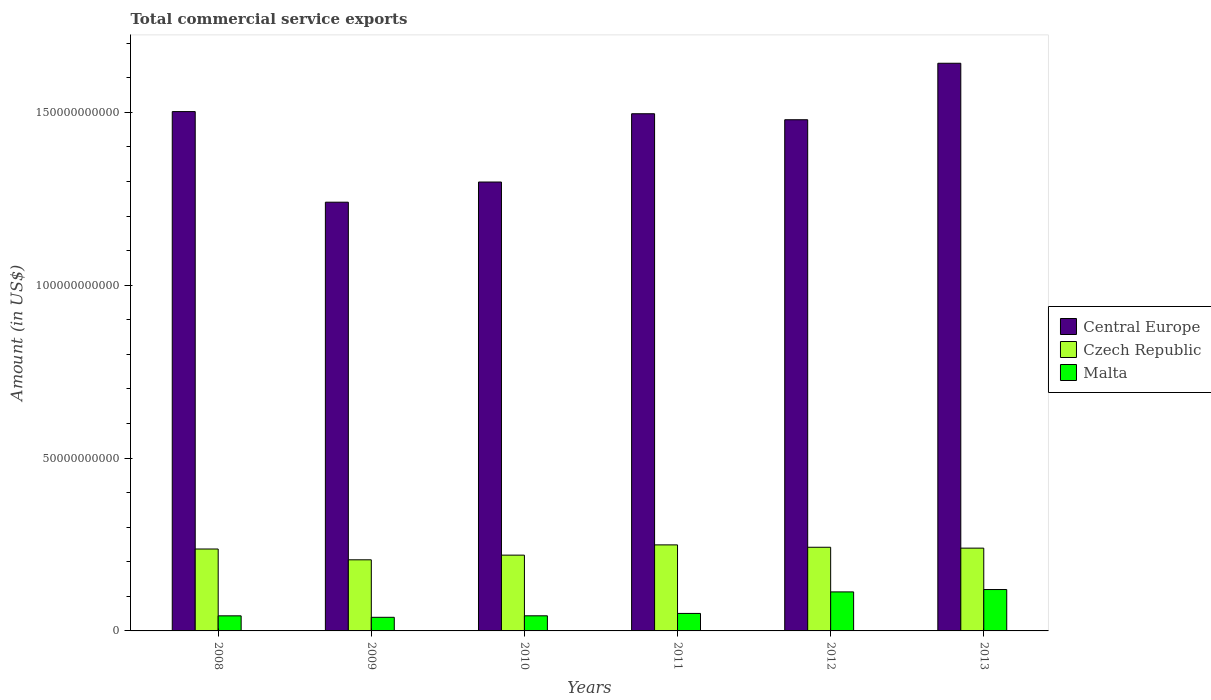Are the number of bars per tick equal to the number of legend labels?
Offer a very short reply. Yes. Are the number of bars on each tick of the X-axis equal?
Your response must be concise. Yes. How many bars are there on the 3rd tick from the left?
Your answer should be very brief. 3. How many bars are there on the 1st tick from the right?
Keep it short and to the point. 3. What is the total commercial service exports in Central Europe in 2008?
Provide a succinct answer. 1.50e+11. Across all years, what is the maximum total commercial service exports in Malta?
Make the answer very short. 1.20e+1. Across all years, what is the minimum total commercial service exports in Czech Republic?
Your response must be concise. 2.06e+1. In which year was the total commercial service exports in Czech Republic maximum?
Provide a short and direct response. 2011. In which year was the total commercial service exports in Central Europe minimum?
Provide a short and direct response. 2009. What is the total total commercial service exports in Czech Republic in the graph?
Your answer should be compact. 1.39e+11. What is the difference between the total commercial service exports in Czech Republic in 2009 and that in 2010?
Provide a succinct answer. -1.35e+09. What is the difference between the total commercial service exports in Central Europe in 2011 and the total commercial service exports in Czech Republic in 2009?
Keep it short and to the point. 1.29e+11. What is the average total commercial service exports in Central Europe per year?
Provide a short and direct response. 1.44e+11. In the year 2010, what is the difference between the total commercial service exports in Czech Republic and total commercial service exports in Central Europe?
Give a very brief answer. -1.08e+11. What is the ratio of the total commercial service exports in Central Europe in 2009 to that in 2012?
Provide a short and direct response. 0.84. Is the difference between the total commercial service exports in Czech Republic in 2008 and 2013 greater than the difference between the total commercial service exports in Central Europe in 2008 and 2013?
Offer a terse response. Yes. What is the difference between the highest and the second highest total commercial service exports in Malta?
Offer a very short reply. 6.85e+08. What is the difference between the highest and the lowest total commercial service exports in Czech Republic?
Keep it short and to the point. 4.32e+09. What does the 1st bar from the left in 2012 represents?
Ensure brevity in your answer.  Central Europe. What does the 3rd bar from the right in 2012 represents?
Offer a very short reply. Central Europe. How many bars are there?
Provide a succinct answer. 18. Are all the bars in the graph horizontal?
Keep it short and to the point. No. What is the difference between two consecutive major ticks on the Y-axis?
Ensure brevity in your answer.  5.00e+1. Does the graph contain grids?
Your response must be concise. No. How many legend labels are there?
Keep it short and to the point. 3. How are the legend labels stacked?
Give a very brief answer. Vertical. What is the title of the graph?
Offer a very short reply. Total commercial service exports. What is the Amount (in US$) of Central Europe in 2008?
Your response must be concise. 1.50e+11. What is the Amount (in US$) in Czech Republic in 2008?
Offer a very short reply. 2.37e+1. What is the Amount (in US$) of Malta in 2008?
Your response must be concise. 4.37e+09. What is the Amount (in US$) of Central Europe in 2009?
Your answer should be compact. 1.24e+11. What is the Amount (in US$) in Czech Republic in 2009?
Give a very brief answer. 2.06e+1. What is the Amount (in US$) of Malta in 2009?
Offer a very short reply. 3.94e+09. What is the Amount (in US$) in Central Europe in 2010?
Make the answer very short. 1.30e+11. What is the Amount (in US$) in Czech Republic in 2010?
Keep it short and to the point. 2.19e+1. What is the Amount (in US$) in Malta in 2010?
Your answer should be very brief. 4.37e+09. What is the Amount (in US$) of Central Europe in 2011?
Your response must be concise. 1.50e+11. What is the Amount (in US$) of Czech Republic in 2011?
Give a very brief answer. 2.49e+1. What is the Amount (in US$) of Malta in 2011?
Give a very brief answer. 5.06e+09. What is the Amount (in US$) in Central Europe in 2012?
Offer a very short reply. 1.48e+11. What is the Amount (in US$) in Czech Republic in 2012?
Your answer should be compact. 2.42e+1. What is the Amount (in US$) of Malta in 2012?
Provide a succinct answer. 1.13e+1. What is the Amount (in US$) in Central Europe in 2013?
Your answer should be compact. 1.64e+11. What is the Amount (in US$) in Czech Republic in 2013?
Provide a succinct answer. 2.39e+1. What is the Amount (in US$) of Malta in 2013?
Make the answer very short. 1.20e+1. Across all years, what is the maximum Amount (in US$) in Central Europe?
Provide a short and direct response. 1.64e+11. Across all years, what is the maximum Amount (in US$) in Czech Republic?
Give a very brief answer. 2.49e+1. Across all years, what is the maximum Amount (in US$) of Malta?
Provide a succinct answer. 1.20e+1. Across all years, what is the minimum Amount (in US$) of Central Europe?
Offer a terse response. 1.24e+11. Across all years, what is the minimum Amount (in US$) of Czech Republic?
Keep it short and to the point. 2.06e+1. Across all years, what is the minimum Amount (in US$) of Malta?
Make the answer very short. 3.94e+09. What is the total Amount (in US$) in Central Europe in the graph?
Offer a very short reply. 8.66e+11. What is the total Amount (in US$) in Czech Republic in the graph?
Offer a very short reply. 1.39e+11. What is the total Amount (in US$) in Malta in the graph?
Make the answer very short. 4.10e+1. What is the difference between the Amount (in US$) in Central Europe in 2008 and that in 2009?
Your answer should be very brief. 2.62e+1. What is the difference between the Amount (in US$) in Czech Republic in 2008 and that in 2009?
Keep it short and to the point. 3.12e+09. What is the difference between the Amount (in US$) in Malta in 2008 and that in 2009?
Ensure brevity in your answer.  4.28e+08. What is the difference between the Amount (in US$) of Central Europe in 2008 and that in 2010?
Ensure brevity in your answer.  2.04e+1. What is the difference between the Amount (in US$) of Czech Republic in 2008 and that in 2010?
Provide a short and direct response. 1.77e+09. What is the difference between the Amount (in US$) in Malta in 2008 and that in 2010?
Provide a succinct answer. -8.65e+06. What is the difference between the Amount (in US$) of Central Europe in 2008 and that in 2011?
Offer a terse response. 6.25e+08. What is the difference between the Amount (in US$) of Czech Republic in 2008 and that in 2011?
Ensure brevity in your answer.  -1.19e+09. What is the difference between the Amount (in US$) of Malta in 2008 and that in 2011?
Offer a very short reply. -6.96e+08. What is the difference between the Amount (in US$) of Central Europe in 2008 and that in 2012?
Your answer should be compact. 2.36e+09. What is the difference between the Amount (in US$) in Czech Republic in 2008 and that in 2012?
Your answer should be very brief. -5.06e+08. What is the difference between the Amount (in US$) in Malta in 2008 and that in 2012?
Offer a very short reply. -6.92e+09. What is the difference between the Amount (in US$) of Central Europe in 2008 and that in 2013?
Make the answer very short. -1.40e+1. What is the difference between the Amount (in US$) of Czech Republic in 2008 and that in 2013?
Provide a short and direct response. -2.54e+08. What is the difference between the Amount (in US$) in Malta in 2008 and that in 2013?
Keep it short and to the point. -7.61e+09. What is the difference between the Amount (in US$) of Central Europe in 2009 and that in 2010?
Give a very brief answer. -5.83e+09. What is the difference between the Amount (in US$) in Czech Republic in 2009 and that in 2010?
Provide a succinct answer. -1.35e+09. What is the difference between the Amount (in US$) in Malta in 2009 and that in 2010?
Provide a succinct answer. -4.36e+08. What is the difference between the Amount (in US$) in Central Europe in 2009 and that in 2011?
Make the answer very short. -2.56e+1. What is the difference between the Amount (in US$) in Czech Republic in 2009 and that in 2011?
Provide a succinct answer. -4.32e+09. What is the difference between the Amount (in US$) in Malta in 2009 and that in 2011?
Give a very brief answer. -1.12e+09. What is the difference between the Amount (in US$) in Central Europe in 2009 and that in 2012?
Provide a short and direct response. -2.39e+1. What is the difference between the Amount (in US$) of Czech Republic in 2009 and that in 2012?
Make the answer very short. -3.63e+09. What is the difference between the Amount (in US$) of Malta in 2009 and that in 2012?
Provide a short and direct response. -7.35e+09. What is the difference between the Amount (in US$) in Central Europe in 2009 and that in 2013?
Ensure brevity in your answer.  -4.02e+1. What is the difference between the Amount (in US$) of Czech Republic in 2009 and that in 2013?
Your response must be concise. -3.38e+09. What is the difference between the Amount (in US$) in Malta in 2009 and that in 2013?
Provide a short and direct response. -8.03e+09. What is the difference between the Amount (in US$) of Central Europe in 2010 and that in 2011?
Keep it short and to the point. -1.98e+1. What is the difference between the Amount (in US$) in Czech Republic in 2010 and that in 2011?
Offer a very short reply. -2.96e+09. What is the difference between the Amount (in US$) of Malta in 2010 and that in 2011?
Provide a short and direct response. -6.87e+08. What is the difference between the Amount (in US$) of Central Europe in 2010 and that in 2012?
Give a very brief answer. -1.80e+1. What is the difference between the Amount (in US$) in Czech Republic in 2010 and that in 2012?
Make the answer very short. -2.28e+09. What is the difference between the Amount (in US$) of Malta in 2010 and that in 2012?
Keep it short and to the point. -6.91e+09. What is the difference between the Amount (in US$) of Central Europe in 2010 and that in 2013?
Offer a very short reply. -3.44e+1. What is the difference between the Amount (in US$) of Czech Republic in 2010 and that in 2013?
Provide a short and direct response. -2.02e+09. What is the difference between the Amount (in US$) in Malta in 2010 and that in 2013?
Your answer should be very brief. -7.60e+09. What is the difference between the Amount (in US$) in Central Europe in 2011 and that in 2012?
Make the answer very short. 1.73e+09. What is the difference between the Amount (in US$) in Czech Republic in 2011 and that in 2012?
Offer a very short reply. 6.84e+08. What is the difference between the Amount (in US$) of Malta in 2011 and that in 2012?
Keep it short and to the point. -6.23e+09. What is the difference between the Amount (in US$) of Central Europe in 2011 and that in 2013?
Give a very brief answer. -1.46e+1. What is the difference between the Amount (in US$) in Czech Republic in 2011 and that in 2013?
Offer a terse response. 9.36e+08. What is the difference between the Amount (in US$) of Malta in 2011 and that in 2013?
Your response must be concise. -6.91e+09. What is the difference between the Amount (in US$) of Central Europe in 2012 and that in 2013?
Your response must be concise. -1.63e+1. What is the difference between the Amount (in US$) in Czech Republic in 2012 and that in 2013?
Provide a short and direct response. 2.52e+08. What is the difference between the Amount (in US$) in Malta in 2012 and that in 2013?
Offer a terse response. -6.85e+08. What is the difference between the Amount (in US$) in Central Europe in 2008 and the Amount (in US$) in Czech Republic in 2009?
Offer a very short reply. 1.30e+11. What is the difference between the Amount (in US$) of Central Europe in 2008 and the Amount (in US$) of Malta in 2009?
Keep it short and to the point. 1.46e+11. What is the difference between the Amount (in US$) in Czech Republic in 2008 and the Amount (in US$) in Malta in 2009?
Give a very brief answer. 1.98e+1. What is the difference between the Amount (in US$) in Central Europe in 2008 and the Amount (in US$) in Czech Republic in 2010?
Provide a succinct answer. 1.28e+11. What is the difference between the Amount (in US$) in Central Europe in 2008 and the Amount (in US$) in Malta in 2010?
Provide a short and direct response. 1.46e+11. What is the difference between the Amount (in US$) in Czech Republic in 2008 and the Amount (in US$) in Malta in 2010?
Your answer should be compact. 1.93e+1. What is the difference between the Amount (in US$) of Central Europe in 2008 and the Amount (in US$) of Czech Republic in 2011?
Your response must be concise. 1.25e+11. What is the difference between the Amount (in US$) of Central Europe in 2008 and the Amount (in US$) of Malta in 2011?
Provide a succinct answer. 1.45e+11. What is the difference between the Amount (in US$) of Czech Republic in 2008 and the Amount (in US$) of Malta in 2011?
Keep it short and to the point. 1.86e+1. What is the difference between the Amount (in US$) in Central Europe in 2008 and the Amount (in US$) in Czech Republic in 2012?
Provide a succinct answer. 1.26e+11. What is the difference between the Amount (in US$) in Central Europe in 2008 and the Amount (in US$) in Malta in 2012?
Provide a succinct answer. 1.39e+11. What is the difference between the Amount (in US$) in Czech Republic in 2008 and the Amount (in US$) in Malta in 2012?
Your answer should be compact. 1.24e+1. What is the difference between the Amount (in US$) in Central Europe in 2008 and the Amount (in US$) in Czech Republic in 2013?
Provide a short and direct response. 1.26e+11. What is the difference between the Amount (in US$) of Central Europe in 2008 and the Amount (in US$) of Malta in 2013?
Give a very brief answer. 1.38e+11. What is the difference between the Amount (in US$) in Czech Republic in 2008 and the Amount (in US$) in Malta in 2013?
Your answer should be very brief. 1.17e+1. What is the difference between the Amount (in US$) of Central Europe in 2009 and the Amount (in US$) of Czech Republic in 2010?
Offer a very short reply. 1.02e+11. What is the difference between the Amount (in US$) of Central Europe in 2009 and the Amount (in US$) of Malta in 2010?
Give a very brief answer. 1.20e+11. What is the difference between the Amount (in US$) in Czech Republic in 2009 and the Amount (in US$) in Malta in 2010?
Make the answer very short. 1.62e+1. What is the difference between the Amount (in US$) of Central Europe in 2009 and the Amount (in US$) of Czech Republic in 2011?
Offer a very short reply. 9.91e+1. What is the difference between the Amount (in US$) in Central Europe in 2009 and the Amount (in US$) in Malta in 2011?
Keep it short and to the point. 1.19e+11. What is the difference between the Amount (in US$) of Czech Republic in 2009 and the Amount (in US$) of Malta in 2011?
Ensure brevity in your answer.  1.55e+1. What is the difference between the Amount (in US$) in Central Europe in 2009 and the Amount (in US$) in Czech Republic in 2012?
Ensure brevity in your answer.  9.98e+1. What is the difference between the Amount (in US$) of Central Europe in 2009 and the Amount (in US$) of Malta in 2012?
Give a very brief answer. 1.13e+11. What is the difference between the Amount (in US$) in Czech Republic in 2009 and the Amount (in US$) in Malta in 2012?
Your answer should be very brief. 9.28e+09. What is the difference between the Amount (in US$) in Central Europe in 2009 and the Amount (in US$) in Czech Republic in 2013?
Offer a very short reply. 1.00e+11. What is the difference between the Amount (in US$) in Central Europe in 2009 and the Amount (in US$) in Malta in 2013?
Ensure brevity in your answer.  1.12e+11. What is the difference between the Amount (in US$) of Czech Republic in 2009 and the Amount (in US$) of Malta in 2013?
Your answer should be very brief. 8.60e+09. What is the difference between the Amount (in US$) of Central Europe in 2010 and the Amount (in US$) of Czech Republic in 2011?
Provide a succinct answer. 1.05e+11. What is the difference between the Amount (in US$) of Central Europe in 2010 and the Amount (in US$) of Malta in 2011?
Give a very brief answer. 1.25e+11. What is the difference between the Amount (in US$) in Czech Republic in 2010 and the Amount (in US$) in Malta in 2011?
Provide a succinct answer. 1.69e+1. What is the difference between the Amount (in US$) in Central Europe in 2010 and the Amount (in US$) in Czech Republic in 2012?
Ensure brevity in your answer.  1.06e+11. What is the difference between the Amount (in US$) in Central Europe in 2010 and the Amount (in US$) in Malta in 2012?
Make the answer very short. 1.19e+11. What is the difference between the Amount (in US$) of Czech Republic in 2010 and the Amount (in US$) of Malta in 2012?
Your answer should be very brief. 1.06e+1. What is the difference between the Amount (in US$) of Central Europe in 2010 and the Amount (in US$) of Czech Republic in 2013?
Your answer should be compact. 1.06e+11. What is the difference between the Amount (in US$) in Central Europe in 2010 and the Amount (in US$) in Malta in 2013?
Give a very brief answer. 1.18e+11. What is the difference between the Amount (in US$) of Czech Republic in 2010 and the Amount (in US$) of Malta in 2013?
Your answer should be very brief. 9.95e+09. What is the difference between the Amount (in US$) of Central Europe in 2011 and the Amount (in US$) of Czech Republic in 2012?
Your answer should be compact. 1.25e+11. What is the difference between the Amount (in US$) of Central Europe in 2011 and the Amount (in US$) of Malta in 2012?
Your answer should be very brief. 1.38e+11. What is the difference between the Amount (in US$) of Czech Republic in 2011 and the Amount (in US$) of Malta in 2012?
Keep it short and to the point. 1.36e+1. What is the difference between the Amount (in US$) in Central Europe in 2011 and the Amount (in US$) in Czech Republic in 2013?
Your answer should be very brief. 1.26e+11. What is the difference between the Amount (in US$) of Central Europe in 2011 and the Amount (in US$) of Malta in 2013?
Your answer should be compact. 1.38e+11. What is the difference between the Amount (in US$) of Czech Republic in 2011 and the Amount (in US$) of Malta in 2013?
Provide a short and direct response. 1.29e+1. What is the difference between the Amount (in US$) in Central Europe in 2012 and the Amount (in US$) in Czech Republic in 2013?
Give a very brief answer. 1.24e+11. What is the difference between the Amount (in US$) of Central Europe in 2012 and the Amount (in US$) of Malta in 2013?
Offer a very short reply. 1.36e+11. What is the difference between the Amount (in US$) of Czech Republic in 2012 and the Amount (in US$) of Malta in 2013?
Provide a succinct answer. 1.22e+1. What is the average Amount (in US$) in Central Europe per year?
Offer a terse response. 1.44e+11. What is the average Amount (in US$) of Czech Republic per year?
Provide a short and direct response. 2.32e+1. What is the average Amount (in US$) of Malta per year?
Ensure brevity in your answer.  6.83e+09. In the year 2008, what is the difference between the Amount (in US$) in Central Europe and Amount (in US$) in Czech Republic?
Ensure brevity in your answer.  1.27e+11. In the year 2008, what is the difference between the Amount (in US$) of Central Europe and Amount (in US$) of Malta?
Make the answer very short. 1.46e+11. In the year 2008, what is the difference between the Amount (in US$) of Czech Republic and Amount (in US$) of Malta?
Offer a very short reply. 1.93e+1. In the year 2009, what is the difference between the Amount (in US$) in Central Europe and Amount (in US$) in Czech Republic?
Provide a succinct answer. 1.03e+11. In the year 2009, what is the difference between the Amount (in US$) of Central Europe and Amount (in US$) of Malta?
Your response must be concise. 1.20e+11. In the year 2009, what is the difference between the Amount (in US$) in Czech Republic and Amount (in US$) in Malta?
Your answer should be very brief. 1.66e+1. In the year 2010, what is the difference between the Amount (in US$) of Central Europe and Amount (in US$) of Czech Republic?
Keep it short and to the point. 1.08e+11. In the year 2010, what is the difference between the Amount (in US$) in Central Europe and Amount (in US$) in Malta?
Your response must be concise. 1.25e+11. In the year 2010, what is the difference between the Amount (in US$) in Czech Republic and Amount (in US$) in Malta?
Provide a succinct answer. 1.76e+1. In the year 2011, what is the difference between the Amount (in US$) in Central Europe and Amount (in US$) in Czech Republic?
Offer a terse response. 1.25e+11. In the year 2011, what is the difference between the Amount (in US$) in Central Europe and Amount (in US$) in Malta?
Keep it short and to the point. 1.45e+11. In the year 2011, what is the difference between the Amount (in US$) of Czech Republic and Amount (in US$) of Malta?
Your response must be concise. 1.98e+1. In the year 2012, what is the difference between the Amount (in US$) in Central Europe and Amount (in US$) in Czech Republic?
Your answer should be compact. 1.24e+11. In the year 2012, what is the difference between the Amount (in US$) of Central Europe and Amount (in US$) of Malta?
Give a very brief answer. 1.37e+11. In the year 2012, what is the difference between the Amount (in US$) of Czech Republic and Amount (in US$) of Malta?
Your answer should be compact. 1.29e+1. In the year 2013, what is the difference between the Amount (in US$) of Central Europe and Amount (in US$) of Czech Republic?
Keep it short and to the point. 1.40e+11. In the year 2013, what is the difference between the Amount (in US$) of Central Europe and Amount (in US$) of Malta?
Offer a terse response. 1.52e+11. In the year 2013, what is the difference between the Amount (in US$) of Czech Republic and Amount (in US$) of Malta?
Keep it short and to the point. 1.20e+1. What is the ratio of the Amount (in US$) in Central Europe in 2008 to that in 2009?
Your response must be concise. 1.21. What is the ratio of the Amount (in US$) in Czech Republic in 2008 to that in 2009?
Your response must be concise. 1.15. What is the ratio of the Amount (in US$) in Malta in 2008 to that in 2009?
Provide a succinct answer. 1.11. What is the ratio of the Amount (in US$) of Central Europe in 2008 to that in 2010?
Offer a terse response. 1.16. What is the ratio of the Amount (in US$) of Czech Republic in 2008 to that in 2010?
Your response must be concise. 1.08. What is the ratio of the Amount (in US$) of Czech Republic in 2008 to that in 2011?
Ensure brevity in your answer.  0.95. What is the ratio of the Amount (in US$) of Malta in 2008 to that in 2011?
Your response must be concise. 0.86. What is the ratio of the Amount (in US$) in Central Europe in 2008 to that in 2012?
Your answer should be very brief. 1.02. What is the ratio of the Amount (in US$) in Czech Republic in 2008 to that in 2012?
Provide a succinct answer. 0.98. What is the ratio of the Amount (in US$) of Malta in 2008 to that in 2012?
Make the answer very short. 0.39. What is the ratio of the Amount (in US$) in Central Europe in 2008 to that in 2013?
Provide a short and direct response. 0.91. What is the ratio of the Amount (in US$) of Czech Republic in 2008 to that in 2013?
Ensure brevity in your answer.  0.99. What is the ratio of the Amount (in US$) of Malta in 2008 to that in 2013?
Your response must be concise. 0.36. What is the ratio of the Amount (in US$) in Central Europe in 2009 to that in 2010?
Your answer should be very brief. 0.96. What is the ratio of the Amount (in US$) of Czech Republic in 2009 to that in 2010?
Ensure brevity in your answer.  0.94. What is the ratio of the Amount (in US$) in Malta in 2009 to that in 2010?
Offer a terse response. 0.9. What is the ratio of the Amount (in US$) of Central Europe in 2009 to that in 2011?
Ensure brevity in your answer.  0.83. What is the ratio of the Amount (in US$) of Czech Republic in 2009 to that in 2011?
Your response must be concise. 0.83. What is the ratio of the Amount (in US$) of Malta in 2009 to that in 2011?
Your answer should be very brief. 0.78. What is the ratio of the Amount (in US$) of Central Europe in 2009 to that in 2012?
Make the answer very short. 0.84. What is the ratio of the Amount (in US$) in Czech Republic in 2009 to that in 2012?
Your answer should be compact. 0.85. What is the ratio of the Amount (in US$) of Malta in 2009 to that in 2012?
Offer a very short reply. 0.35. What is the ratio of the Amount (in US$) of Central Europe in 2009 to that in 2013?
Keep it short and to the point. 0.76. What is the ratio of the Amount (in US$) in Czech Republic in 2009 to that in 2013?
Your response must be concise. 0.86. What is the ratio of the Amount (in US$) of Malta in 2009 to that in 2013?
Your answer should be compact. 0.33. What is the ratio of the Amount (in US$) of Central Europe in 2010 to that in 2011?
Ensure brevity in your answer.  0.87. What is the ratio of the Amount (in US$) of Czech Republic in 2010 to that in 2011?
Your answer should be compact. 0.88. What is the ratio of the Amount (in US$) in Malta in 2010 to that in 2011?
Make the answer very short. 0.86. What is the ratio of the Amount (in US$) in Central Europe in 2010 to that in 2012?
Provide a succinct answer. 0.88. What is the ratio of the Amount (in US$) in Czech Republic in 2010 to that in 2012?
Your answer should be very brief. 0.91. What is the ratio of the Amount (in US$) of Malta in 2010 to that in 2012?
Keep it short and to the point. 0.39. What is the ratio of the Amount (in US$) of Central Europe in 2010 to that in 2013?
Provide a succinct answer. 0.79. What is the ratio of the Amount (in US$) of Czech Republic in 2010 to that in 2013?
Offer a terse response. 0.92. What is the ratio of the Amount (in US$) in Malta in 2010 to that in 2013?
Your response must be concise. 0.37. What is the ratio of the Amount (in US$) in Central Europe in 2011 to that in 2012?
Your answer should be very brief. 1.01. What is the ratio of the Amount (in US$) of Czech Republic in 2011 to that in 2012?
Give a very brief answer. 1.03. What is the ratio of the Amount (in US$) in Malta in 2011 to that in 2012?
Provide a short and direct response. 0.45. What is the ratio of the Amount (in US$) in Central Europe in 2011 to that in 2013?
Make the answer very short. 0.91. What is the ratio of the Amount (in US$) of Czech Republic in 2011 to that in 2013?
Offer a terse response. 1.04. What is the ratio of the Amount (in US$) in Malta in 2011 to that in 2013?
Give a very brief answer. 0.42. What is the ratio of the Amount (in US$) in Central Europe in 2012 to that in 2013?
Provide a short and direct response. 0.9. What is the ratio of the Amount (in US$) of Czech Republic in 2012 to that in 2013?
Make the answer very short. 1.01. What is the ratio of the Amount (in US$) of Malta in 2012 to that in 2013?
Keep it short and to the point. 0.94. What is the difference between the highest and the second highest Amount (in US$) of Central Europe?
Your response must be concise. 1.40e+1. What is the difference between the highest and the second highest Amount (in US$) of Czech Republic?
Keep it short and to the point. 6.84e+08. What is the difference between the highest and the second highest Amount (in US$) of Malta?
Give a very brief answer. 6.85e+08. What is the difference between the highest and the lowest Amount (in US$) of Central Europe?
Your answer should be compact. 4.02e+1. What is the difference between the highest and the lowest Amount (in US$) in Czech Republic?
Make the answer very short. 4.32e+09. What is the difference between the highest and the lowest Amount (in US$) of Malta?
Provide a succinct answer. 8.03e+09. 